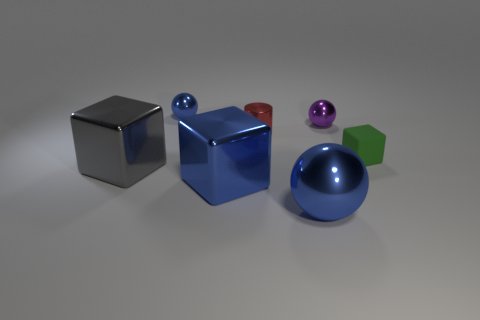What is the large blue sphere made of?
Make the answer very short. Metal. There is a blue ball on the right side of the tiny blue shiny object; how big is it?
Ensure brevity in your answer.  Large. Is there anything else that has the same color as the large metal sphere?
Your answer should be compact. Yes. Are there any big blue things in front of the red shiny cylinder that is to the right of the blue object behind the green rubber object?
Keep it short and to the point. Yes. There is a shiny block that is on the right side of the big gray shiny thing; is its color the same as the large metallic sphere?
Make the answer very short. Yes. What number of blocks are shiny things or purple shiny things?
Give a very brief answer. 2. What shape is the red object behind the large blue metallic thing that is to the right of the small red shiny object?
Ensure brevity in your answer.  Cylinder. There is a metal sphere in front of the tiny ball that is in front of the blue metal object behind the tiny green rubber cube; how big is it?
Offer a very short reply. Large. Does the green thing have the same size as the metallic cylinder?
Offer a very short reply. Yes. How many things are either metal balls or purple rubber balls?
Give a very brief answer. 3. 